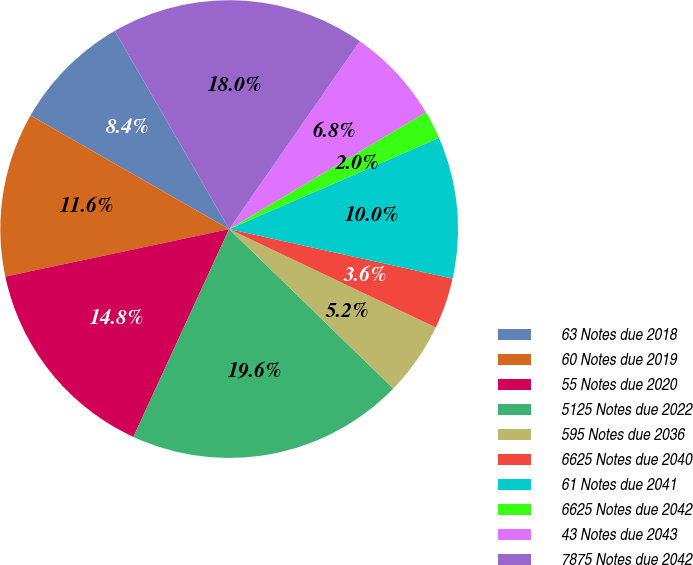<chart> <loc_0><loc_0><loc_500><loc_500><pie_chart><fcel>63 Notes due 2018<fcel>60 Notes due 2019<fcel>55 Notes due 2020<fcel>5125 Notes due 2022<fcel>595 Notes due 2036<fcel>6625 Notes due 2040<fcel>61 Notes due 2041<fcel>6625 Notes due 2042<fcel>43 Notes due 2043<fcel>7875 Notes due 2042<nl><fcel>8.4%<fcel>11.6%<fcel>14.8%<fcel>19.6%<fcel>5.2%<fcel>3.6%<fcel>10.0%<fcel>2.0%<fcel>6.8%<fcel>18.0%<nl></chart> 